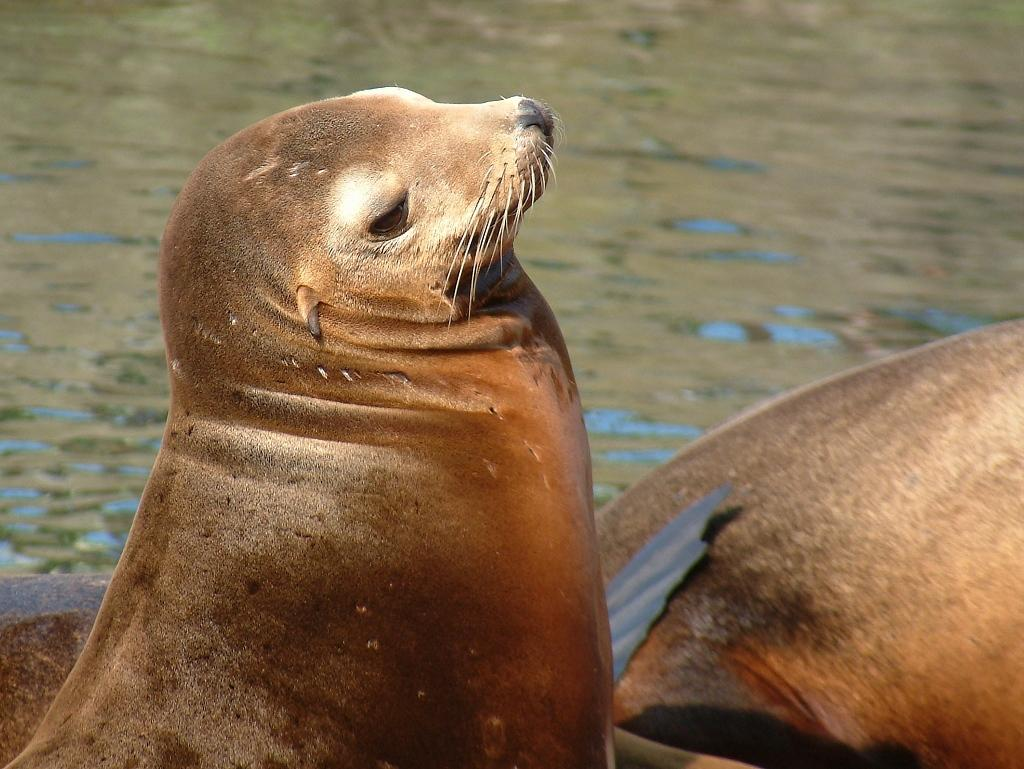What animals are present in the image? There are seals in the image. What type of environment can be seen in the background of the image? There is water visible in the background of the image. What type of pleasure can be seen in the image? There is no reference to pleasure in the image; it features seals in a water environment. 